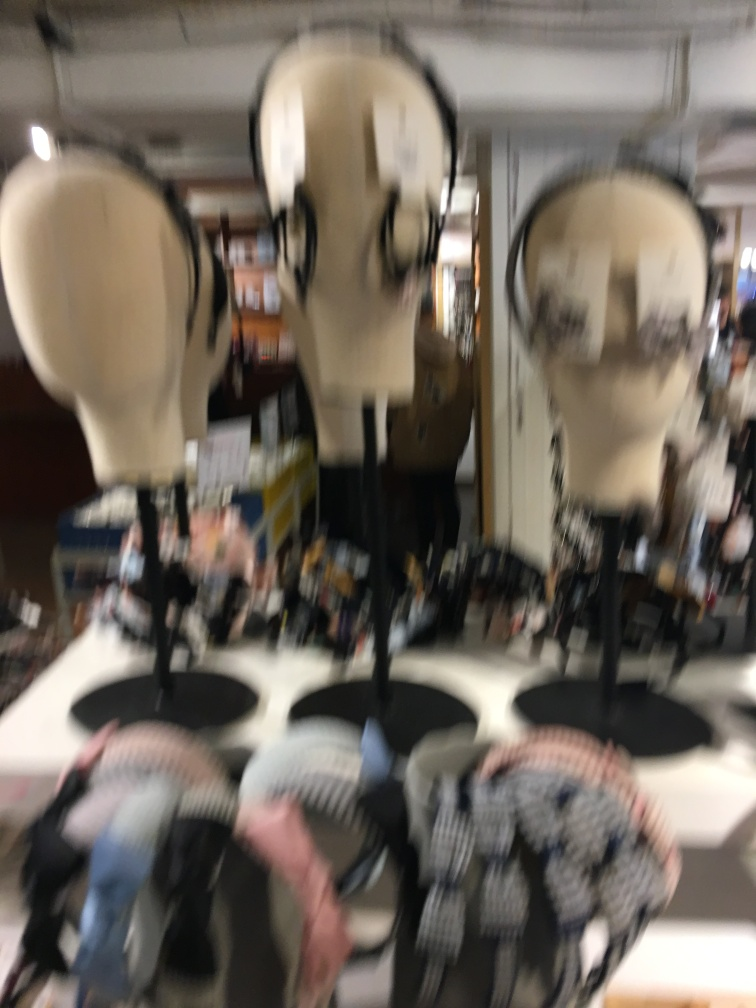What might be the possible reasons for the blurred image? The blurriness could be due to several factors, such as a camera shake during the shot, incorrect focus settings on the camera, a fast-moving subject, or a deliberate artistic choice to create an impressionistic effect. 